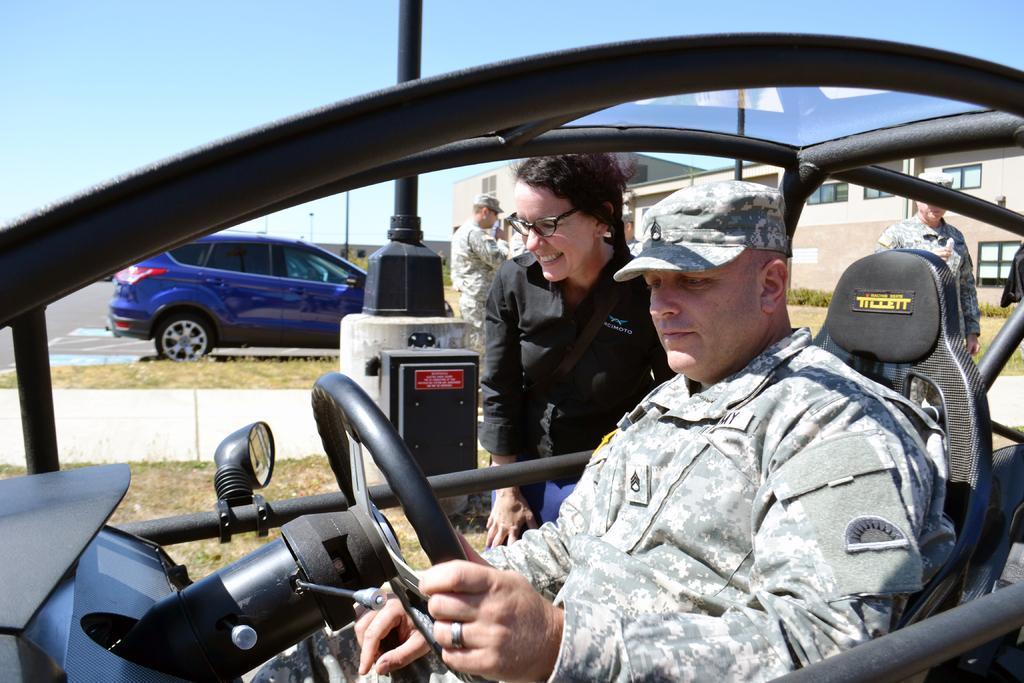Describe this image in one or two sentences. In this image there were two persons, one man and one woman. Man was sitting inside the vehicle and holding the steering. He is wearing a cap and light colored shirt. A woman standing besides the vehicle and smiling. She is wearing black shirt and blue jeans besides her there were some people standing and moving around. In the background there is a blue truck, building, some plants and blue sky. 